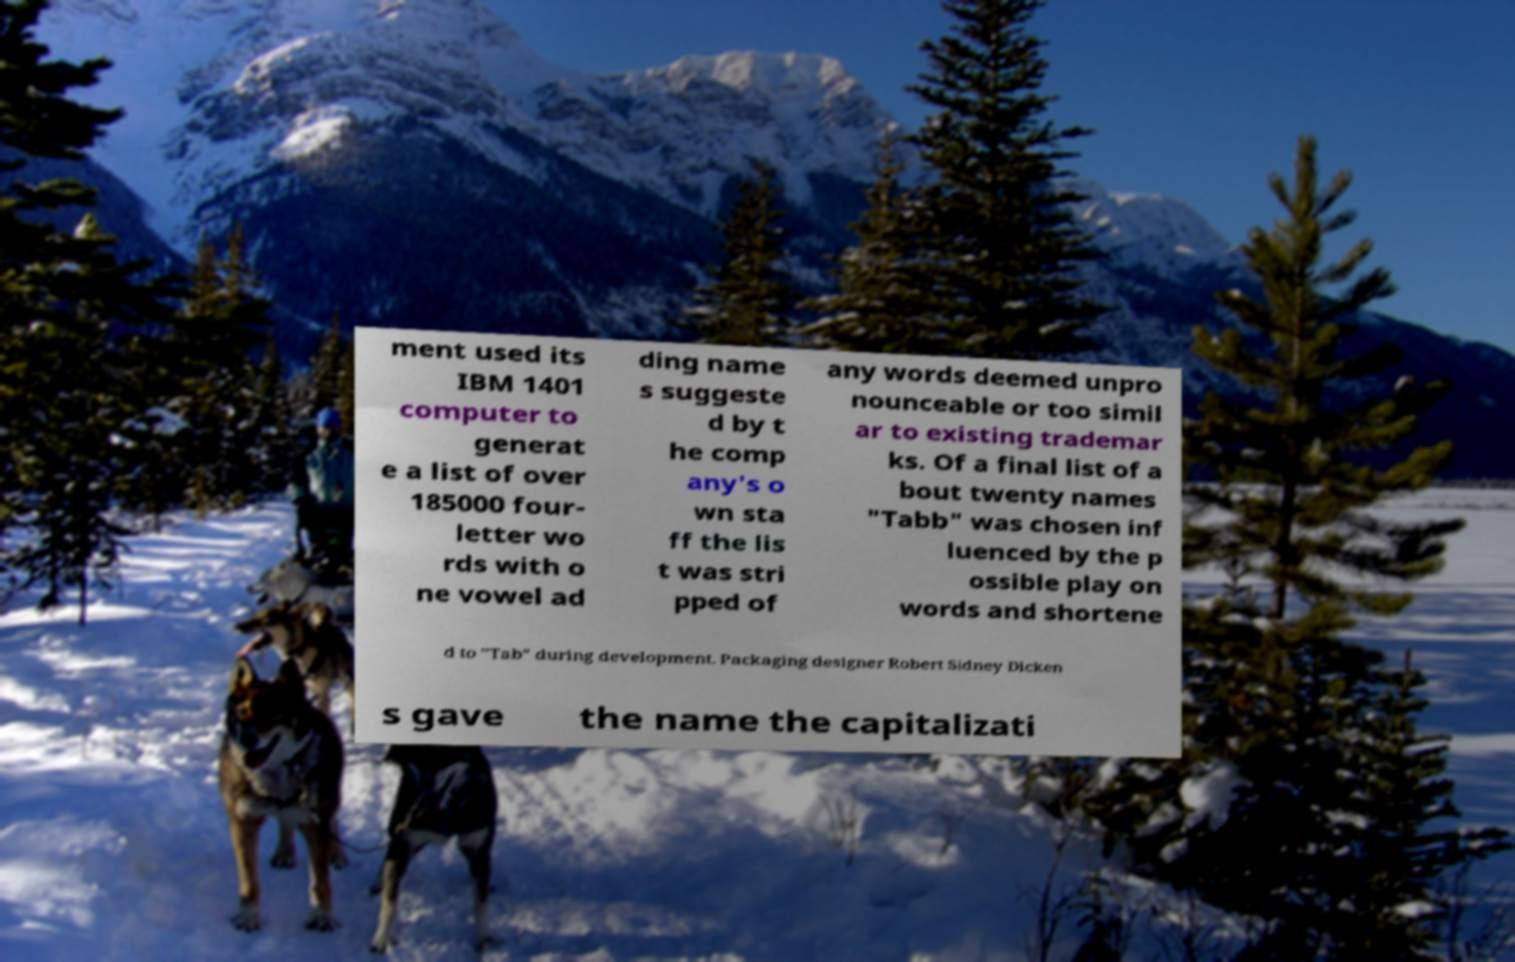Please read and relay the text visible in this image. What does it say? ment used its IBM 1401 computer to generat e a list of over 185000 four- letter wo rds with o ne vowel ad ding name s suggeste d by t he comp any's o wn sta ff the lis t was stri pped of any words deemed unpro nounceable or too simil ar to existing trademar ks. Of a final list of a bout twenty names "Tabb" was chosen inf luenced by the p ossible play on words and shortene d to "Tab" during development. Packaging designer Robert Sidney Dicken s gave the name the capitalizati 